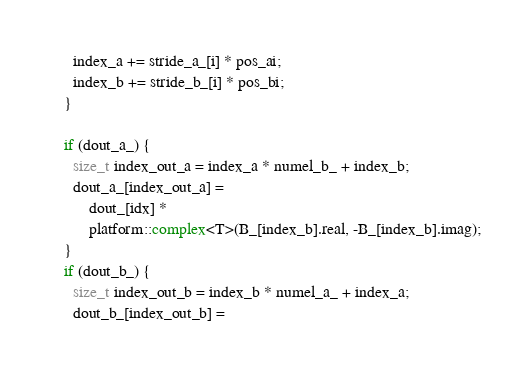Convert code to text. <code><loc_0><loc_0><loc_500><loc_500><_C_>      index_a += stride_a_[i] * pos_ai;
      index_b += stride_b_[i] * pos_bi;
    }

    if (dout_a_) {
      size_t index_out_a = index_a * numel_b_ + index_b;
      dout_a_[index_out_a] =
          dout_[idx] *
          platform::complex<T>(B_[index_b].real, -B_[index_b].imag);
    }
    if (dout_b_) {
      size_t index_out_b = index_b * numel_a_ + index_a;
      dout_b_[index_out_b] =</code> 